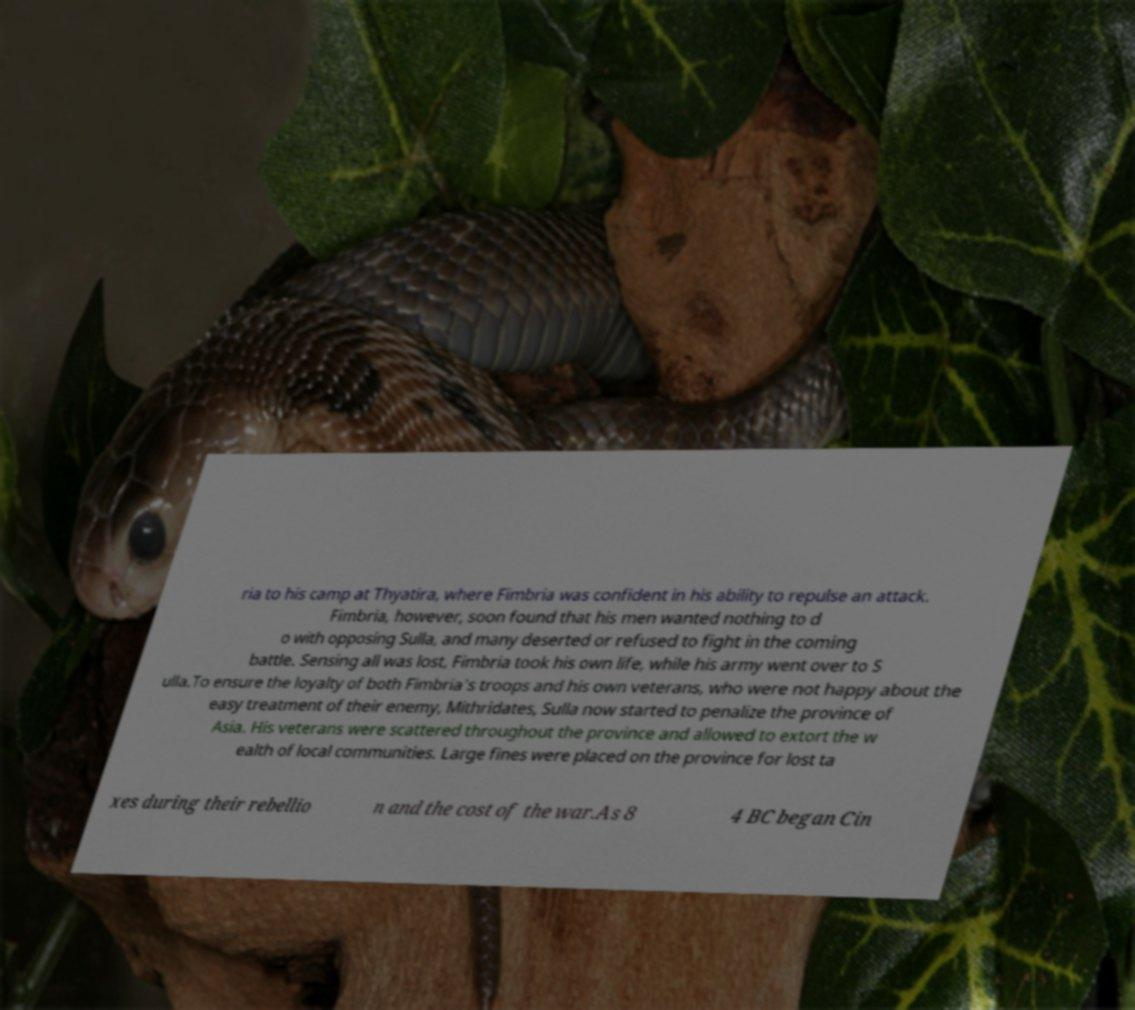Can you accurately transcribe the text from the provided image for me? ria to his camp at Thyatira, where Fimbria was confident in his ability to repulse an attack. Fimbria, however, soon found that his men wanted nothing to d o with opposing Sulla, and many deserted or refused to fight in the coming battle. Sensing all was lost, Fimbria took his own life, while his army went over to S ulla.To ensure the loyalty of both Fimbria's troops and his own veterans, who were not happy about the easy treatment of their enemy, Mithridates, Sulla now started to penalize the province of Asia. His veterans were scattered throughout the province and allowed to extort the w ealth of local communities. Large fines were placed on the province for lost ta xes during their rebellio n and the cost of the war.As 8 4 BC began Cin 